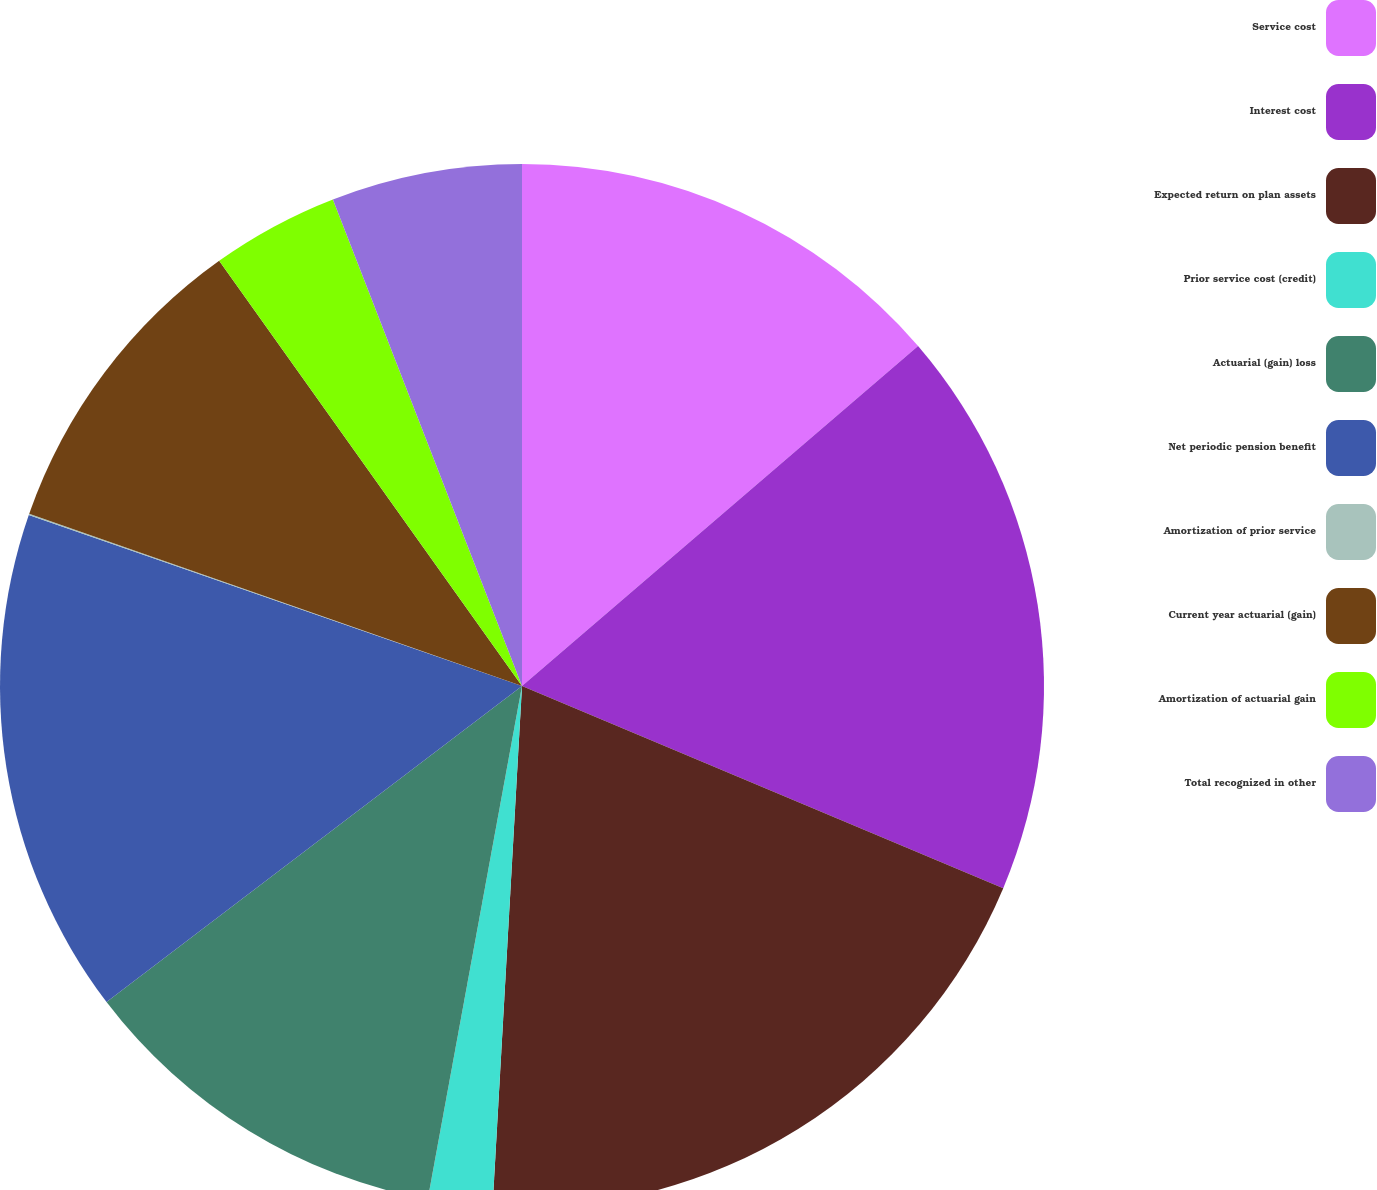Convert chart. <chart><loc_0><loc_0><loc_500><loc_500><pie_chart><fcel>Service cost<fcel>Interest cost<fcel>Expected return on plan assets<fcel>Prior service cost (credit)<fcel>Actuarial (gain) loss<fcel>Net periodic pension benefit<fcel>Amortization of prior service<fcel>Current year actuarial (gain)<fcel>Amortization of actuarial gain<fcel>Total recognized in other<nl><fcel>13.71%<fcel>17.62%<fcel>19.57%<fcel>1.99%<fcel>11.76%<fcel>15.66%<fcel>0.04%<fcel>9.8%<fcel>3.95%<fcel>5.9%<nl></chart> 